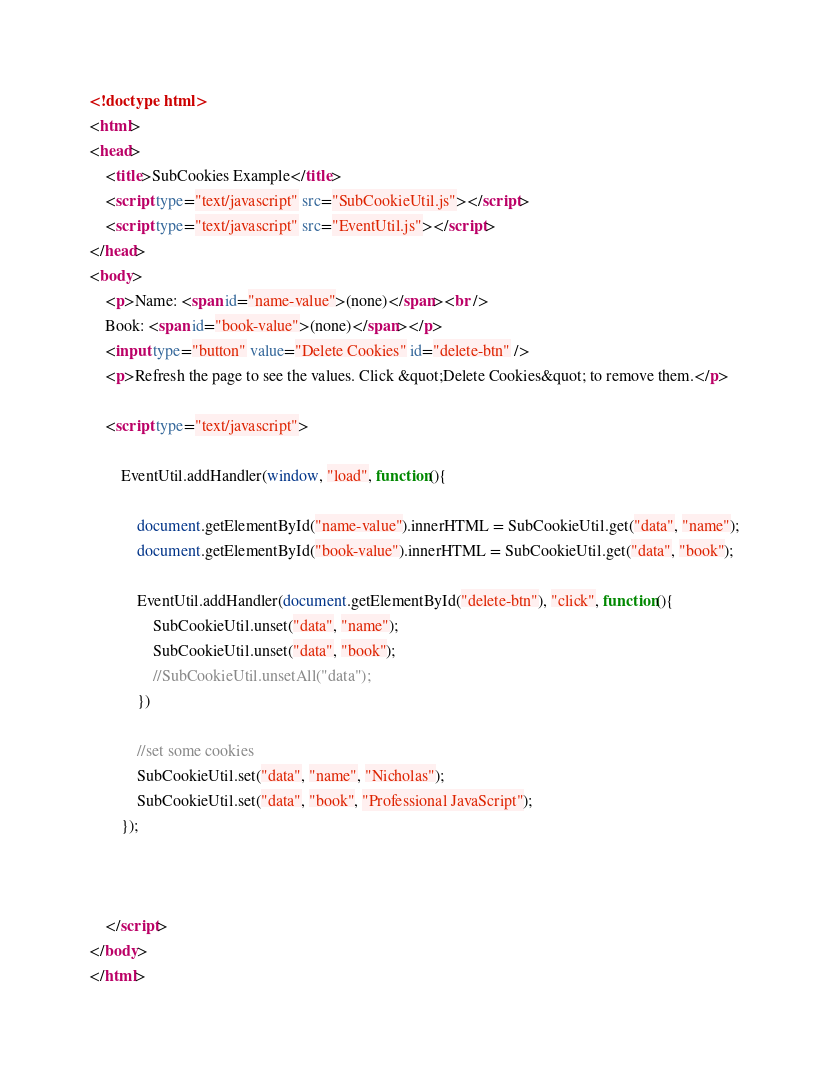<code> <loc_0><loc_0><loc_500><loc_500><_HTML_><!doctype html>
<html>
<head>
    <title>SubCookies Example</title>
    <script type="text/javascript" src="SubCookieUtil.js"></script>
    <script type="text/javascript" src="EventUtil.js"></script>
</head>
<body>
    <p>Name: <span id="name-value">(none)</span><br />
    Book: <span id="book-value">(none)</span></p>
    <input type="button" value="Delete Cookies" id="delete-btn" />
    <p>Refresh the page to see the values. Click &quot;Delete Cookies&quot; to remove them.</p>

    <script type="text/javascript">
        
        EventUtil.addHandler(window, "load", function(){

            document.getElementById("name-value").innerHTML = SubCookieUtil.get("data", "name");
            document.getElementById("book-value").innerHTML = SubCookieUtil.get("data", "book");
        
            EventUtil.addHandler(document.getElementById("delete-btn"), "click", function(){
                SubCookieUtil.unset("data", "name");
                SubCookieUtil.unset("data", "book");      
                //SubCookieUtil.unsetAll("data");      
            })
            
            //set some cookies
            SubCookieUtil.set("data", "name", "Nicholas");
            SubCookieUtil.set("data", "book", "Professional JavaScript");
        });



    </script>
</body>
</html>
</code> 